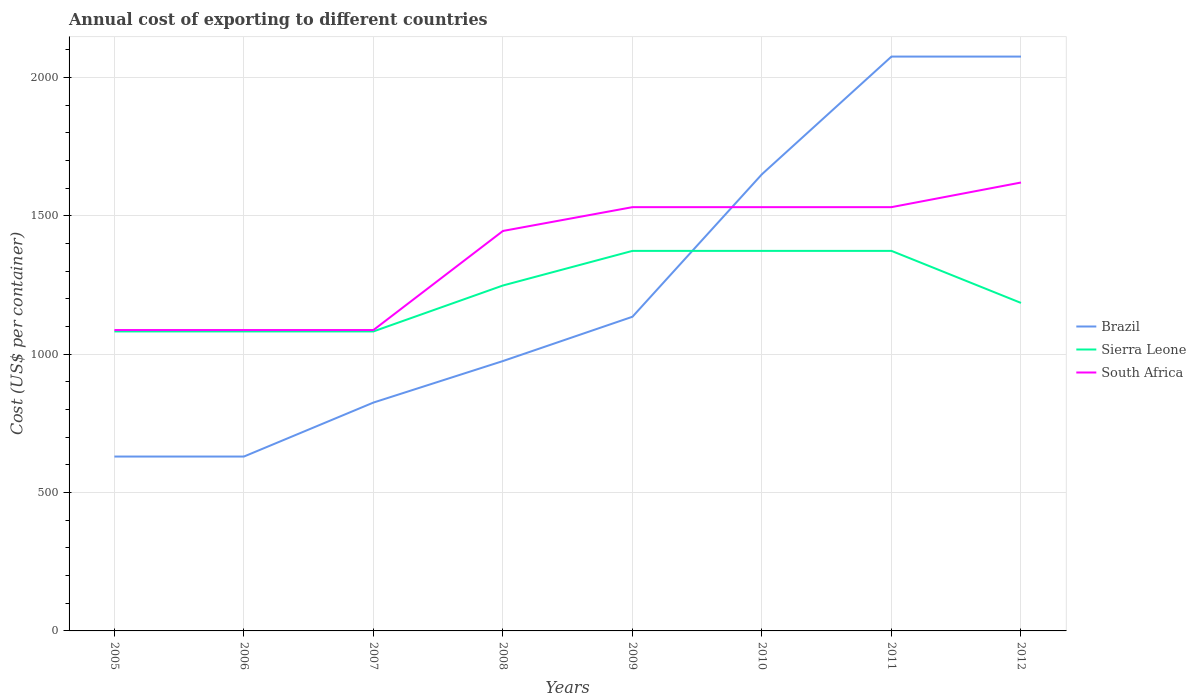Across all years, what is the maximum total annual cost of exporting in South Africa?
Give a very brief answer. 1087. In which year was the total annual cost of exporting in Brazil maximum?
Provide a short and direct response. 2005. What is the total total annual cost of exporting in Brazil in the graph?
Offer a terse response. -310. What is the difference between the highest and the second highest total annual cost of exporting in Brazil?
Your response must be concise. 1445. Is the total annual cost of exporting in Brazil strictly greater than the total annual cost of exporting in South Africa over the years?
Provide a succinct answer. No. How many years are there in the graph?
Keep it short and to the point. 8. What is the difference between two consecutive major ticks on the Y-axis?
Offer a terse response. 500. Where does the legend appear in the graph?
Provide a short and direct response. Center right. How many legend labels are there?
Offer a terse response. 3. How are the legend labels stacked?
Offer a terse response. Vertical. What is the title of the graph?
Your answer should be very brief. Annual cost of exporting to different countries. What is the label or title of the X-axis?
Keep it short and to the point. Years. What is the label or title of the Y-axis?
Keep it short and to the point. Cost (US$ per container). What is the Cost (US$ per container) of Brazil in 2005?
Keep it short and to the point. 630. What is the Cost (US$ per container) of Sierra Leone in 2005?
Make the answer very short. 1082. What is the Cost (US$ per container) of South Africa in 2005?
Give a very brief answer. 1087. What is the Cost (US$ per container) in Brazil in 2006?
Offer a very short reply. 630. What is the Cost (US$ per container) in Sierra Leone in 2006?
Give a very brief answer. 1082. What is the Cost (US$ per container) of South Africa in 2006?
Offer a very short reply. 1087. What is the Cost (US$ per container) in Brazil in 2007?
Provide a succinct answer. 825. What is the Cost (US$ per container) in Sierra Leone in 2007?
Offer a terse response. 1082. What is the Cost (US$ per container) of South Africa in 2007?
Keep it short and to the point. 1087. What is the Cost (US$ per container) of Brazil in 2008?
Keep it short and to the point. 975. What is the Cost (US$ per container) of Sierra Leone in 2008?
Provide a short and direct response. 1248. What is the Cost (US$ per container) of South Africa in 2008?
Your response must be concise. 1445. What is the Cost (US$ per container) in Brazil in 2009?
Offer a very short reply. 1135. What is the Cost (US$ per container) in Sierra Leone in 2009?
Provide a short and direct response. 1373. What is the Cost (US$ per container) of South Africa in 2009?
Ensure brevity in your answer.  1531. What is the Cost (US$ per container) of Brazil in 2010?
Offer a very short reply. 1650. What is the Cost (US$ per container) in Sierra Leone in 2010?
Give a very brief answer. 1373. What is the Cost (US$ per container) of South Africa in 2010?
Offer a terse response. 1531. What is the Cost (US$ per container) of Brazil in 2011?
Keep it short and to the point. 2075. What is the Cost (US$ per container) of Sierra Leone in 2011?
Your answer should be very brief. 1373. What is the Cost (US$ per container) in South Africa in 2011?
Your answer should be compact. 1531. What is the Cost (US$ per container) of Brazil in 2012?
Offer a terse response. 2075. What is the Cost (US$ per container) in Sierra Leone in 2012?
Your answer should be compact. 1185. What is the Cost (US$ per container) of South Africa in 2012?
Offer a terse response. 1620. Across all years, what is the maximum Cost (US$ per container) of Brazil?
Provide a short and direct response. 2075. Across all years, what is the maximum Cost (US$ per container) of Sierra Leone?
Give a very brief answer. 1373. Across all years, what is the maximum Cost (US$ per container) in South Africa?
Provide a short and direct response. 1620. Across all years, what is the minimum Cost (US$ per container) in Brazil?
Make the answer very short. 630. Across all years, what is the minimum Cost (US$ per container) in Sierra Leone?
Keep it short and to the point. 1082. Across all years, what is the minimum Cost (US$ per container) in South Africa?
Your answer should be compact. 1087. What is the total Cost (US$ per container) of Brazil in the graph?
Your answer should be compact. 9995. What is the total Cost (US$ per container) in Sierra Leone in the graph?
Offer a terse response. 9798. What is the total Cost (US$ per container) in South Africa in the graph?
Your response must be concise. 1.09e+04. What is the difference between the Cost (US$ per container) of Brazil in 2005 and that in 2007?
Provide a succinct answer. -195. What is the difference between the Cost (US$ per container) of Sierra Leone in 2005 and that in 2007?
Ensure brevity in your answer.  0. What is the difference between the Cost (US$ per container) of Brazil in 2005 and that in 2008?
Ensure brevity in your answer.  -345. What is the difference between the Cost (US$ per container) of Sierra Leone in 2005 and that in 2008?
Your response must be concise. -166. What is the difference between the Cost (US$ per container) of South Africa in 2005 and that in 2008?
Keep it short and to the point. -358. What is the difference between the Cost (US$ per container) of Brazil in 2005 and that in 2009?
Keep it short and to the point. -505. What is the difference between the Cost (US$ per container) of Sierra Leone in 2005 and that in 2009?
Provide a succinct answer. -291. What is the difference between the Cost (US$ per container) in South Africa in 2005 and that in 2009?
Your response must be concise. -444. What is the difference between the Cost (US$ per container) in Brazil in 2005 and that in 2010?
Provide a short and direct response. -1020. What is the difference between the Cost (US$ per container) in Sierra Leone in 2005 and that in 2010?
Your answer should be compact. -291. What is the difference between the Cost (US$ per container) in South Africa in 2005 and that in 2010?
Offer a very short reply. -444. What is the difference between the Cost (US$ per container) in Brazil in 2005 and that in 2011?
Provide a succinct answer. -1445. What is the difference between the Cost (US$ per container) of Sierra Leone in 2005 and that in 2011?
Your answer should be compact. -291. What is the difference between the Cost (US$ per container) in South Africa in 2005 and that in 2011?
Provide a short and direct response. -444. What is the difference between the Cost (US$ per container) of Brazil in 2005 and that in 2012?
Your answer should be compact. -1445. What is the difference between the Cost (US$ per container) in Sierra Leone in 2005 and that in 2012?
Your answer should be very brief. -103. What is the difference between the Cost (US$ per container) of South Africa in 2005 and that in 2012?
Make the answer very short. -533. What is the difference between the Cost (US$ per container) in Brazil in 2006 and that in 2007?
Your answer should be very brief. -195. What is the difference between the Cost (US$ per container) in South Africa in 2006 and that in 2007?
Your answer should be very brief. 0. What is the difference between the Cost (US$ per container) of Brazil in 2006 and that in 2008?
Your answer should be very brief. -345. What is the difference between the Cost (US$ per container) of Sierra Leone in 2006 and that in 2008?
Make the answer very short. -166. What is the difference between the Cost (US$ per container) in South Africa in 2006 and that in 2008?
Your response must be concise. -358. What is the difference between the Cost (US$ per container) of Brazil in 2006 and that in 2009?
Ensure brevity in your answer.  -505. What is the difference between the Cost (US$ per container) in Sierra Leone in 2006 and that in 2009?
Keep it short and to the point. -291. What is the difference between the Cost (US$ per container) in South Africa in 2006 and that in 2009?
Offer a terse response. -444. What is the difference between the Cost (US$ per container) of Brazil in 2006 and that in 2010?
Ensure brevity in your answer.  -1020. What is the difference between the Cost (US$ per container) in Sierra Leone in 2006 and that in 2010?
Your response must be concise. -291. What is the difference between the Cost (US$ per container) in South Africa in 2006 and that in 2010?
Provide a succinct answer. -444. What is the difference between the Cost (US$ per container) in Brazil in 2006 and that in 2011?
Your response must be concise. -1445. What is the difference between the Cost (US$ per container) in Sierra Leone in 2006 and that in 2011?
Keep it short and to the point. -291. What is the difference between the Cost (US$ per container) in South Africa in 2006 and that in 2011?
Make the answer very short. -444. What is the difference between the Cost (US$ per container) in Brazil in 2006 and that in 2012?
Offer a terse response. -1445. What is the difference between the Cost (US$ per container) of Sierra Leone in 2006 and that in 2012?
Your answer should be compact. -103. What is the difference between the Cost (US$ per container) in South Africa in 2006 and that in 2012?
Provide a succinct answer. -533. What is the difference between the Cost (US$ per container) in Brazil in 2007 and that in 2008?
Keep it short and to the point. -150. What is the difference between the Cost (US$ per container) in Sierra Leone in 2007 and that in 2008?
Offer a terse response. -166. What is the difference between the Cost (US$ per container) in South Africa in 2007 and that in 2008?
Keep it short and to the point. -358. What is the difference between the Cost (US$ per container) in Brazil in 2007 and that in 2009?
Offer a terse response. -310. What is the difference between the Cost (US$ per container) of Sierra Leone in 2007 and that in 2009?
Offer a very short reply. -291. What is the difference between the Cost (US$ per container) in South Africa in 2007 and that in 2009?
Your answer should be compact. -444. What is the difference between the Cost (US$ per container) of Brazil in 2007 and that in 2010?
Provide a short and direct response. -825. What is the difference between the Cost (US$ per container) in Sierra Leone in 2007 and that in 2010?
Provide a short and direct response. -291. What is the difference between the Cost (US$ per container) in South Africa in 2007 and that in 2010?
Offer a terse response. -444. What is the difference between the Cost (US$ per container) in Brazil in 2007 and that in 2011?
Your response must be concise. -1250. What is the difference between the Cost (US$ per container) of Sierra Leone in 2007 and that in 2011?
Give a very brief answer. -291. What is the difference between the Cost (US$ per container) in South Africa in 2007 and that in 2011?
Your answer should be compact. -444. What is the difference between the Cost (US$ per container) in Brazil in 2007 and that in 2012?
Your answer should be compact. -1250. What is the difference between the Cost (US$ per container) of Sierra Leone in 2007 and that in 2012?
Make the answer very short. -103. What is the difference between the Cost (US$ per container) in South Africa in 2007 and that in 2012?
Your answer should be compact. -533. What is the difference between the Cost (US$ per container) in Brazil in 2008 and that in 2009?
Your response must be concise. -160. What is the difference between the Cost (US$ per container) in Sierra Leone in 2008 and that in 2009?
Offer a terse response. -125. What is the difference between the Cost (US$ per container) of South Africa in 2008 and that in 2009?
Offer a very short reply. -86. What is the difference between the Cost (US$ per container) of Brazil in 2008 and that in 2010?
Your response must be concise. -675. What is the difference between the Cost (US$ per container) in Sierra Leone in 2008 and that in 2010?
Ensure brevity in your answer.  -125. What is the difference between the Cost (US$ per container) in South Africa in 2008 and that in 2010?
Make the answer very short. -86. What is the difference between the Cost (US$ per container) of Brazil in 2008 and that in 2011?
Your answer should be very brief. -1100. What is the difference between the Cost (US$ per container) of Sierra Leone in 2008 and that in 2011?
Your answer should be very brief. -125. What is the difference between the Cost (US$ per container) in South Africa in 2008 and that in 2011?
Offer a very short reply. -86. What is the difference between the Cost (US$ per container) in Brazil in 2008 and that in 2012?
Your response must be concise. -1100. What is the difference between the Cost (US$ per container) of South Africa in 2008 and that in 2012?
Your answer should be compact. -175. What is the difference between the Cost (US$ per container) of Brazil in 2009 and that in 2010?
Offer a very short reply. -515. What is the difference between the Cost (US$ per container) of South Africa in 2009 and that in 2010?
Make the answer very short. 0. What is the difference between the Cost (US$ per container) of Brazil in 2009 and that in 2011?
Your response must be concise. -940. What is the difference between the Cost (US$ per container) of Sierra Leone in 2009 and that in 2011?
Your response must be concise. 0. What is the difference between the Cost (US$ per container) in South Africa in 2009 and that in 2011?
Your answer should be very brief. 0. What is the difference between the Cost (US$ per container) in Brazil in 2009 and that in 2012?
Provide a succinct answer. -940. What is the difference between the Cost (US$ per container) of Sierra Leone in 2009 and that in 2012?
Provide a short and direct response. 188. What is the difference between the Cost (US$ per container) in South Africa in 2009 and that in 2012?
Give a very brief answer. -89. What is the difference between the Cost (US$ per container) of Brazil in 2010 and that in 2011?
Provide a short and direct response. -425. What is the difference between the Cost (US$ per container) in Sierra Leone in 2010 and that in 2011?
Your response must be concise. 0. What is the difference between the Cost (US$ per container) in South Africa in 2010 and that in 2011?
Your answer should be compact. 0. What is the difference between the Cost (US$ per container) of Brazil in 2010 and that in 2012?
Provide a succinct answer. -425. What is the difference between the Cost (US$ per container) of Sierra Leone in 2010 and that in 2012?
Offer a very short reply. 188. What is the difference between the Cost (US$ per container) of South Africa in 2010 and that in 2012?
Make the answer very short. -89. What is the difference between the Cost (US$ per container) in Sierra Leone in 2011 and that in 2012?
Provide a succinct answer. 188. What is the difference between the Cost (US$ per container) in South Africa in 2011 and that in 2012?
Give a very brief answer. -89. What is the difference between the Cost (US$ per container) in Brazil in 2005 and the Cost (US$ per container) in Sierra Leone in 2006?
Your response must be concise. -452. What is the difference between the Cost (US$ per container) in Brazil in 2005 and the Cost (US$ per container) in South Africa in 2006?
Offer a very short reply. -457. What is the difference between the Cost (US$ per container) in Sierra Leone in 2005 and the Cost (US$ per container) in South Africa in 2006?
Your answer should be compact. -5. What is the difference between the Cost (US$ per container) of Brazil in 2005 and the Cost (US$ per container) of Sierra Leone in 2007?
Ensure brevity in your answer.  -452. What is the difference between the Cost (US$ per container) of Brazil in 2005 and the Cost (US$ per container) of South Africa in 2007?
Your answer should be compact. -457. What is the difference between the Cost (US$ per container) in Brazil in 2005 and the Cost (US$ per container) in Sierra Leone in 2008?
Keep it short and to the point. -618. What is the difference between the Cost (US$ per container) in Brazil in 2005 and the Cost (US$ per container) in South Africa in 2008?
Keep it short and to the point. -815. What is the difference between the Cost (US$ per container) of Sierra Leone in 2005 and the Cost (US$ per container) of South Africa in 2008?
Keep it short and to the point. -363. What is the difference between the Cost (US$ per container) in Brazil in 2005 and the Cost (US$ per container) in Sierra Leone in 2009?
Your answer should be very brief. -743. What is the difference between the Cost (US$ per container) in Brazil in 2005 and the Cost (US$ per container) in South Africa in 2009?
Offer a very short reply. -901. What is the difference between the Cost (US$ per container) in Sierra Leone in 2005 and the Cost (US$ per container) in South Africa in 2009?
Provide a succinct answer. -449. What is the difference between the Cost (US$ per container) of Brazil in 2005 and the Cost (US$ per container) of Sierra Leone in 2010?
Make the answer very short. -743. What is the difference between the Cost (US$ per container) of Brazil in 2005 and the Cost (US$ per container) of South Africa in 2010?
Provide a short and direct response. -901. What is the difference between the Cost (US$ per container) of Sierra Leone in 2005 and the Cost (US$ per container) of South Africa in 2010?
Your answer should be very brief. -449. What is the difference between the Cost (US$ per container) of Brazil in 2005 and the Cost (US$ per container) of Sierra Leone in 2011?
Offer a very short reply. -743. What is the difference between the Cost (US$ per container) of Brazil in 2005 and the Cost (US$ per container) of South Africa in 2011?
Offer a terse response. -901. What is the difference between the Cost (US$ per container) of Sierra Leone in 2005 and the Cost (US$ per container) of South Africa in 2011?
Provide a succinct answer. -449. What is the difference between the Cost (US$ per container) of Brazil in 2005 and the Cost (US$ per container) of Sierra Leone in 2012?
Your response must be concise. -555. What is the difference between the Cost (US$ per container) of Brazil in 2005 and the Cost (US$ per container) of South Africa in 2012?
Provide a short and direct response. -990. What is the difference between the Cost (US$ per container) of Sierra Leone in 2005 and the Cost (US$ per container) of South Africa in 2012?
Your answer should be compact. -538. What is the difference between the Cost (US$ per container) of Brazil in 2006 and the Cost (US$ per container) of Sierra Leone in 2007?
Make the answer very short. -452. What is the difference between the Cost (US$ per container) in Brazil in 2006 and the Cost (US$ per container) in South Africa in 2007?
Provide a short and direct response. -457. What is the difference between the Cost (US$ per container) in Brazil in 2006 and the Cost (US$ per container) in Sierra Leone in 2008?
Make the answer very short. -618. What is the difference between the Cost (US$ per container) of Brazil in 2006 and the Cost (US$ per container) of South Africa in 2008?
Ensure brevity in your answer.  -815. What is the difference between the Cost (US$ per container) of Sierra Leone in 2006 and the Cost (US$ per container) of South Africa in 2008?
Ensure brevity in your answer.  -363. What is the difference between the Cost (US$ per container) of Brazil in 2006 and the Cost (US$ per container) of Sierra Leone in 2009?
Give a very brief answer. -743. What is the difference between the Cost (US$ per container) of Brazil in 2006 and the Cost (US$ per container) of South Africa in 2009?
Provide a short and direct response. -901. What is the difference between the Cost (US$ per container) in Sierra Leone in 2006 and the Cost (US$ per container) in South Africa in 2009?
Your answer should be compact. -449. What is the difference between the Cost (US$ per container) of Brazil in 2006 and the Cost (US$ per container) of Sierra Leone in 2010?
Keep it short and to the point. -743. What is the difference between the Cost (US$ per container) of Brazil in 2006 and the Cost (US$ per container) of South Africa in 2010?
Provide a short and direct response. -901. What is the difference between the Cost (US$ per container) of Sierra Leone in 2006 and the Cost (US$ per container) of South Africa in 2010?
Make the answer very short. -449. What is the difference between the Cost (US$ per container) in Brazil in 2006 and the Cost (US$ per container) in Sierra Leone in 2011?
Keep it short and to the point. -743. What is the difference between the Cost (US$ per container) of Brazil in 2006 and the Cost (US$ per container) of South Africa in 2011?
Provide a short and direct response. -901. What is the difference between the Cost (US$ per container) in Sierra Leone in 2006 and the Cost (US$ per container) in South Africa in 2011?
Your answer should be compact. -449. What is the difference between the Cost (US$ per container) in Brazil in 2006 and the Cost (US$ per container) in Sierra Leone in 2012?
Your response must be concise. -555. What is the difference between the Cost (US$ per container) in Brazil in 2006 and the Cost (US$ per container) in South Africa in 2012?
Provide a succinct answer. -990. What is the difference between the Cost (US$ per container) in Sierra Leone in 2006 and the Cost (US$ per container) in South Africa in 2012?
Ensure brevity in your answer.  -538. What is the difference between the Cost (US$ per container) in Brazil in 2007 and the Cost (US$ per container) in Sierra Leone in 2008?
Your response must be concise. -423. What is the difference between the Cost (US$ per container) of Brazil in 2007 and the Cost (US$ per container) of South Africa in 2008?
Your response must be concise. -620. What is the difference between the Cost (US$ per container) in Sierra Leone in 2007 and the Cost (US$ per container) in South Africa in 2008?
Make the answer very short. -363. What is the difference between the Cost (US$ per container) of Brazil in 2007 and the Cost (US$ per container) of Sierra Leone in 2009?
Offer a terse response. -548. What is the difference between the Cost (US$ per container) of Brazil in 2007 and the Cost (US$ per container) of South Africa in 2009?
Offer a terse response. -706. What is the difference between the Cost (US$ per container) of Sierra Leone in 2007 and the Cost (US$ per container) of South Africa in 2009?
Keep it short and to the point. -449. What is the difference between the Cost (US$ per container) of Brazil in 2007 and the Cost (US$ per container) of Sierra Leone in 2010?
Ensure brevity in your answer.  -548. What is the difference between the Cost (US$ per container) in Brazil in 2007 and the Cost (US$ per container) in South Africa in 2010?
Provide a short and direct response. -706. What is the difference between the Cost (US$ per container) in Sierra Leone in 2007 and the Cost (US$ per container) in South Africa in 2010?
Provide a succinct answer. -449. What is the difference between the Cost (US$ per container) in Brazil in 2007 and the Cost (US$ per container) in Sierra Leone in 2011?
Your response must be concise. -548. What is the difference between the Cost (US$ per container) of Brazil in 2007 and the Cost (US$ per container) of South Africa in 2011?
Your response must be concise. -706. What is the difference between the Cost (US$ per container) of Sierra Leone in 2007 and the Cost (US$ per container) of South Africa in 2011?
Your answer should be compact. -449. What is the difference between the Cost (US$ per container) in Brazil in 2007 and the Cost (US$ per container) in Sierra Leone in 2012?
Ensure brevity in your answer.  -360. What is the difference between the Cost (US$ per container) in Brazil in 2007 and the Cost (US$ per container) in South Africa in 2012?
Your answer should be compact. -795. What is the difference between the Cost (US$ per container) in Sierra Leone in 2007 and the Cost (US$ per container) in South Africa in 2012?
Provide a succinct answer. -538. What is the difference between the Cost (US$ per container) of Brazil in 2008 and the Cost (US$ per container) of Sierra Leone in 2009?
Offer a terse response. -398. What is the difference between the Cost (US$ per container) in Brazil in 2008 and the Cost (US$ per container) in South Africa in 2009?
Give a very brief answer. -556. What is the difference between the Cost (US$ per container) in Sierra Leone in 2008 and the Cost (US$ per container) in South Africa in 2009?
Offer a very short reply. -283. What is the difference between the Cost (US$ per container) in Brazil in 2008 and the Cost (US$ per container) in Sierra Leone in 2010?
Provide a short and direct response. -398. What is the difference between the Cost (US$ per container) in Brazil in 2008 and the Cost (US$ per container) in South Africa in 2010?
Ensure brevity in your answer.  -556. What is the difference between the Cost (US$ per container) of Sierra Leone in 2008 and the Cost (US$ per container) of South Africa in 2010?
Provide a short and direct response. -283. What is the difference between the Cost (US$ per container) in Brazil in 2008 and the Cost (US$ per container) in Sierra Leone in 2011?
Ensure brevity in your answer.  -398. What is the difference between the Cost (US$ per container) in Brazil in 2008 and the Cost (US$ per container) in South Africa in 2011?
Keep it short and to the point. -556. What is the difference between the Cost (US$ per container) in Sierra Leone in 2008 and the Cost (US$ per container) in South Africa in 2011?
Provide a short and direct response. -283. What is the difference between the Cost (US$ per container) of Brazil in 2008 and the Cost (US$ per container) of Sierra Leone in 2012?
Provide a succinct answer. -210. What is the difference between the Cost (US$ per container) of Brazil in 2008 and the Cost (US$ per container) of South Africa in 2012?
Provide a short and direct response. -645. What is the difference between the Cost (US$ per container) of Sierra Leone in 2008 and the Cost (US$ per container) of South Africa in 2012?
Your response must be concise. -372. What is the difference between the Cost (US$ per container) in Brazil in 2009 and the Cost (US$ per container) in Sierra Leone in 2010?
Provide a succinct answer. -238. What is the difference between the Cost (US$ per container) in Brazil in 2009 and the Cost (US$ per container) in South Africa in 2010?
Your response must be concise. -396. What is the difference between the Cost (US$ per container) of Sierra Leone in 2009 and the Cost (US$ per container) of South Africa in 2010?
Keep it short and to the point. -158. What is the difference between the Cost (US$ per container) of Brazil in 2009 and the Cost (US$ per container) of Sierra Leone in 2011?
Your answer should be very brief. -238. What is the difference between the Cost (US$ per container) in Brazil in 2009 and the Cost (US$ per container) in South Africa in 2011?
Give a very brief answer. -396. What is the difference between the Cost (US$ per container) of Sierra Leone in 2009 and the Cost (US$ per container) of South Africa in 2011?
Provide a short and direct response. -158. What is the difference between the Cost (US$ per container) in Brazil in 2009 and the Cost (US$ per container) in South Africa in 2012?
Make the answer very short. -485. What is the difference between the Cost (US$ per container) of Sierra Leone in 2009 and the Cost (US$ per container) of South Africa in 2012?
Provide a short and direct response. -247. What is the difference between the Cost (US$ per container) in Brazil in 2010 and the Cost (US$ per container) in Sierra Leone in 2011?
Ensure brevity in your answer.  277. What is the difference between the Cost (US$ per container) of Brazil in 2010 and the Cost (US$ per container) of South Africa in 2011?
Provide a succinct answer. 119. What is the difference between the Cost (US$ per container) in Sierra Leone in 2010 and the Cost (US$ per container) in South Africa in 2011?
Offer a terse response. -158. What is the difference between the Cost (US$ per container) of Brazil in 2010 and the Cost (US$ per container) of Sierra Leone in 2012?
Your answer should be very brief. 465. What is the difference between the Cost (US$ per container) in Brazil in 2010 and the Cost (US$ per container) in South Africa in 2012?
Ensure brevity in your answer.  30. What is the difference between the Cost (US$ per container) in Sierra Leone in 2010 and the Cost (US$ per container) in South Africa in 2012?
Your answer should be compact. -247. What is the difference between the Cost (US$ per container) of Brazil in 2011 and the Cost (US$ per container) of Sierra Leone in 2012?
Your response must be concise. 890. What is the difference between the Cost (US$ per container) of Brazil in 2011 and the Cost (US$ per container) of South Africa in 2012?
Make the answer very short. 455. What is the difference between the Cost (US$ per container) in Sierra Leone in 2011 and the Cost (US$ per container) in South Africa in 2012?
Your response must be concise. -247. What is the average Cost (US$ per container) in Brazil per year?
Provide a succinct answer. 1249.38. What is the average Cost (US$ per container) in Sierra Leone per year?
Your response must be concise. 1224.75. What is the average Cost (US$ per container) of South Africa per year?
Give a very brief answer. 1364.88. In the year 2005, what is the difference between the Cost (US$ per container) in Brazil and Cost (US$ per container) in Sierra Leone?
Your response must be concise. -452. In the year 2005, what is the difference between the Cost (US$ per container) of Brazil and Cost (US$ per container) of South Africa?
Offer a very short reply. -457. In the year 2005, what is the difference between the Cost (US$ per container) of Sierra Leone and Cost (US$ per container) of South Africa?
Your answer should be very brief. -5. In the year 2006, what is the difference between the Cost (US$ per container) in Brazil and Cost (US$ per container) in Sierra Leone?
Your response must be concise. -452. In the year 2006, what is the difference between the Cost (US$ per container) of Brazil and Cost (US$ per container) of South Africa?
Your response must be concise. -457. In the year 2007, what is the difference between the Cost (US$ per container) of Brazil and Cost (US$ per container) of Sierra Leone?
Make the answer very short. -257. In the year 2007, what is the difference between the Cost (US$ per container) in Brazil and Cost (US$ per container) in South Africa?
Make the answer very short. -262. In the year 2008, what is the difference between the Cost (US$ per container) of Brazil and Cost (US$ per container) of Sierra Leone?
Keep it short and to the point. -273. In the year 2008, what is the difference between the Cost (US$ per container) of Brazil and Cost (US$ per container) of South Africa?
Keep it short and to the point. -470. In the year 2008, what is the difference between the Cost (US$ per container) in Sierra Leone and Cost (US$ per container) in South Africa?
Offer a very short reply. -197. In the year 2009, what is the difference between the Cost (US$ per container) of Brazil and Cost (US$ per container) of Sierra Leone?
Give a very brief answer. -238. In the year 2009, what is the difference between the Cost (US$ per container) of Brazil and Cost (US$ per container) of South Africa?
Give a very brief answer. -396. In the year 2009, what is the difference between the Cost (US$ per container) in Sierra Leone and Cost (US$ per container) in South Africa?
Provide a succinct answer. -158. In the year 2010, what is the difference between the Cost (US$ per container) in Brazil and Cost (US$ per container) in Sierra Leone?
Keep it short and to the point. 277. In the year 2010, what is the difference between the Cost (US$ per container) of Brazil and Cost (US$ per container) of South Africa?
Make the answer very short. 119. In the year 2010, what is the difference between the Cost (US$ per container) of Sierra Leone and Cost (US$ per container) of South Africa?
Provide a succinct answer. -158. In the year 2011, what is the difference between the Cost (US$ per container) in Brazil and Cost (US$ per container) in Sierra Leone?
Ensure brevity in your answer.  702. In the year 2011, what is the difference between the Cost (US$ per container) in Brazil and Cost (US$ per container) in South Africa?
Keep it short and to the point. 544. In the year 2011, what is the difference between the Cost (US$ per container) of Sierra Leone and Cost (US$ per container) of South Africa?
Provide a short and direct response. -158. In the year 2012, what is the difference between the Cost (US$ per container) of Brazil and Cost (US$ per container) of Sierra Leone?
Provide a short and direct response. 890. In the year 2012, what is the difference between the Cost (US$ per container) of Brazil and Cost (US$ per container) of South Africa?
Your answer should be compact. 455. In the year 2012, what is the difference between the Cost (US$ per container) in Sierra Leone and Cost (US$ per container) in South Africa?
Provide a short and direct response. -435. What is the ratio of the Cost (US$ per container) in Sierra Leone in 2005 to that in 2006?
Your response must be concise. 1. What is the ratio of the Cost (US$ per container) in Brazil in 2005 to that in 2007?
Provide a succinct answer. 0.76. What is the ratio of the Cost (US$ per container) of Sierra Leone in 2005 to that in 2007?
Offer a very short reply. 1. What is the ratio of the Cost (US$ per container) of Brazil in 2005 to that in 2008?
Offer a terse response. 0.65. What is the ratio of the Cost (US$ per container) in Sierra Leone in 2005 to that in 2008?
Make the answer very short. 0.87. What is the ratio of the Cost (US$ per container) in South Africa in 2005 to that in 2008?
Keep it short and to the point. 0.75. What is the ratio of the Cost (US$ per container) in Brazil in 2005 to that in 2009?
Offer a terse response. 0.56. What is the ratio of the Cost (US$ per container) of Sierra Leone in 2005 to that in 2009?
Offer a terse response. 0.79. What is the ratio of the Cost (US$ per container) in South Africa in 2005 to that in 2009?
Make the answer very short. 0.71. What is the ratio of the Cost (US$ per container) in Brazil in 2005 to that in 2010?
Your answer should be very brief. 0.38. What is the ratio of the Cost (US$ per container) of Sierra Leone in 2005 to that in 2010?
Offer a very short reply. 0.79. What is the ratio of the Cost (US$ per container) in South Africa in 2005 to that in 2010?
Your response must be concise. 0.71. What is the ratio of the Cost (US$ per container) of Brazil in 2005 to that in 2011?
Your response must be concise. 0.3. What is the ratio of the Cost (US$ per container) in Sierra Leone in 2005 to that in 2011?
Your answer should be compact. 0.79. What is the ratio of the Cost (US$ per container) in South Africa in 2005 to that in 2011?
Provide a succinct answer. 0.71. What is the ratio of the Cost (US$ per container) of Brazil in 2005 to that in 2012?
Your answer should be compact. 0.3. What is the ratio of the Cost (US$ per container) of Sierra Leone in 2005 to that in 2012?
Provide a short and direct response. 0.91. What is the ratio of the Cost (US$ per container) of South Africa in 2005 to that in 2012?
Your response must be concise. 0.67. What is the ratio of the Cost (US$ per container) of Brazil in 2006 to that in 2007?
Your answer should be very brief. 0.76. What is the ratio of the Cost (US$ per container) of South Africa in 2006 to that in 2007?
Give a very brief answer. 1. What is the ratio of the Cost (US$ per container) in Brazil in 2006 to that in 2008?
Provide a succinct answer. 0.65. What is the ratio of the Cost (US$ per container) in Sierra Leone in 2006 to that in 2008?
Your answer should be very brief. 0.87. What is the ratio of the Cost (US$ per container) of South Africa in 2006 to that in 2008?
Make the answer very short. 0.75. What is the ratio of the Cost (US$ per container) in Brazil in 2006 to that in 2009?
Offer a terse response. 0.56. What is the ratio of the Cost (US$ per container) in Sierra Leone in 2006 to that in 2009?
Make the answer very short. 0.79. What is the ratio of the Cost (US$ per container) of South Africa in 2006 to that in 2009?
Keep it short and to the point. 0.71. What is the ratio of the Cost (US$ per container) of Brazil in 2006 to that in 2010?
Make the answer very short. 0.38. What is the ratio of the Cost (US$ per container) in Sierra Leone in 2006 to that in 2010?
Offer a very short reply. 0.79. What is the ratio of the Cost (US$ per container) in South Africa in 2006 to that in 2010?
Your answer should be compact. 0.71. What is the ratio of the Cost (US$ per container) of Brazil in 2006 to that in 2011?
Your answer should be compact. 0.3. What is the ratio of the Cost (US$ per container) of Sierra Leone in 2006 to that in 2011?
Your answer should be compact. 0.79. What is the ratio of the Cost (US$ per container) of South Africa in 2006 to that in 2011?
Make the answer very short. 0.71. What is the ratio of the Cost (US$ per container) in Brazil in 2006 to that in 2012?
Keep it short and to the point. 0.3. What is the ratio of the Cost (US$ per container) in Sierra Leone in 2006 to that in 2012?
Keep it short and to the point. 0.91. What is the ratio of the Cost (US$ per container) of South Africa in 2006 to that in 2012?
Ensure brevity in your answer.  0.67. What is the ratio of the Cost (US$ per container) in Brazil in 2007 to that in 2008?
Make the answer very short. 0.85. What is the ratio of the Cost (US$ per container) of Sierra Leone in 2007 to that in 2008?
Make the answer very short. 0.87. What is the ratio of the Cost (US$ per container) in South Africa in 2007 to that in 2008?
Give a very brief answer. 0.75. What is the ratio of the Cost (US$ per container) in Brazil in 2007 to that in 2009?
Ensure brevity in your answer.  0.73. What is the ratio of the Cost (US$ per container) in Sierra Leone in 2007 to that in 2009?
Make the answer very short. 0.79. What is the ratio of the Cost (US$ per container) in South Africa in 2007 to that in 2009?
Give a very brief answer. 0.71. What is the ratio of the Cost (US$ per container) in Sierra Leone in 2007 to that in 2010?
Give a very brief answer. 0.79. What is the ratio of the Cost (US$ per container) in South Africa in 2007 to that in 2010?
Make the answer very short. 0.71. What is the ratio of the Cost (US$ per container) of Brazil in 2007 to that in 2011?
Offer a terse response. 0.4. What is the ratio of the Cost (US$ per container) of Sierra Leone in 2007 to that in 2011?
Keep it short and to the point. 0.79. What is the ratio of the Cost (US$ per container) of South Africa in 2007 to that in 2011?
Offer a terse response. 0.71. What is the ratio of the Cost (US$ per container) in Brazil in 2007 to that in 2012?
Provide a short and direct response. 0.4. What is the ratio of the Cost (US$ per container) in Sierra Leone in 2007 to that in 2012?
Offer a very short reply. 0.91. What is the ratio of the Cost (US$ per container) of South Africa in 2007 to that in 2012?
Your response must be concise. 0.67. What is the ratio of the Cost (US$ per container) in Brazil in 2008 to that in 2009?
Offer a terse response. 0.86. What is the ratio of the Cost (US$ per container) of Sierra Leone in 2008 to that in 2009?
Make the answer very short. 0.91. What is the ratio of the Cost (US$ per container) of South Africa in 2008 to that in 2009?
Your answer should be compact. 0.94. What is the ratio of the Cost (US$ per container) of Brazil in 2008 to that in 2010?
Provide a succinct answer. 0.59. What is the ratio of the Cost (US$ per container) of Sierra Leone in 2008 to that in 2010?
Your response must be concise. 0.91. What is the ratio of the Cost (US$ per container) in South Africa in 2008 to that in 2010?
Offer a terse response. 0.94. What is the ratio of the Cost (US$ per container) in Brazil in 2008 to that in 2011?
Provide a short and direct response. 0.47. What is the ratio of the Cost (US$ per container) in Sierra Leone in 2008 to that in 2011?
Ensure brevity in your answer.  0.91. What is the ratio of the Cost (US$ per container) in South Africa in 2008 to that in 2011?
Give a very brief answer. 0.94. What is the ratio of the Cost (US$ per container) of Brazil in 2008 to that in 2012?
Offer a terse response. 0.47. What is the ratio of the Cost (US$ per container) in Sierra Leone in 2008 to that in 2012?
Offer a terse response. 1.05. What is the ratio of the Cost (US$ per container) of South Africa in 2008 to that in 2012?
Make the answer very short. 0.89. What is the ratio of the Cost (US$ per container) of Brazil in 2009 to that in 2010?
Offer a very short reply. 0.69. What is the ratio of the Cost (US$ per container) of Brazil in 2009 to that in 2011?
Provide a succinct answer. 0.55. What is the ratio of the Cost (US$ per container) in Brazil in 2009 to that in 2012?
Keep it short and to the point. 0.55. What is the ratio of the Cost (US$ per container) of Sierra Leone in 2009 to that in 2012?
Give a very brief answer. 1.16. What is the ratio of the Cost (US$ per container) of South Africa in 2009 to that in 2012?
Ensure brevity in your answer.  0.95. What is the ratio of the Cost (US$ per container) of Brazil in 2010 to that in 2011?
Keep it short and to the point. 0.8. What is the ratio of the Cost (US$ per container) in Sierra Leone in 2010 to that in 2011?
Offer a very short reply. 1. What is the ratio of the Cost (US$ per container) in Brazil in 2010 to that in 2012?
Provide a short and direct response. 0.8. What is the ratio of the Cost (US$ per container) of Sierra Leone in 2010 to that in 2012?
Keep it short and to the point. 1.16. What is the ratio of the Cost (US$ per container) in South Africa in 2010 to that in 2012?
Your response must be concise. 0.95. What is the ratio of the Cost (US$ per container) of Sierra Leone in 2011 to that in 2012?
Your answer should be very brief. 1.16. What is the ratio of the Cost (US$ per container) in South Africa in 2011 to that in 2012?
Provide a succinct answer. 0.95. What is the difference between the highest and the second highest Cost (US$ per container) of Brazil?
Offer a terse response. 0. What is the difference between the highest and the second highest Cost (US$ per container) of South Africa?
Give a very brief answer. 89. What is the difference between the highest and the lowest Cost (US$ per container) of Brazil?
Provide a succinct answer. 1445. What is the difference between the highest and the lowest Cost (US$ per container) in Sierra Leone?
Give a very brief answer. 291. What is the difference between the highest and the lowest Cost (US$ per container) of South Africa?
Provide a succinct answer. 533. 